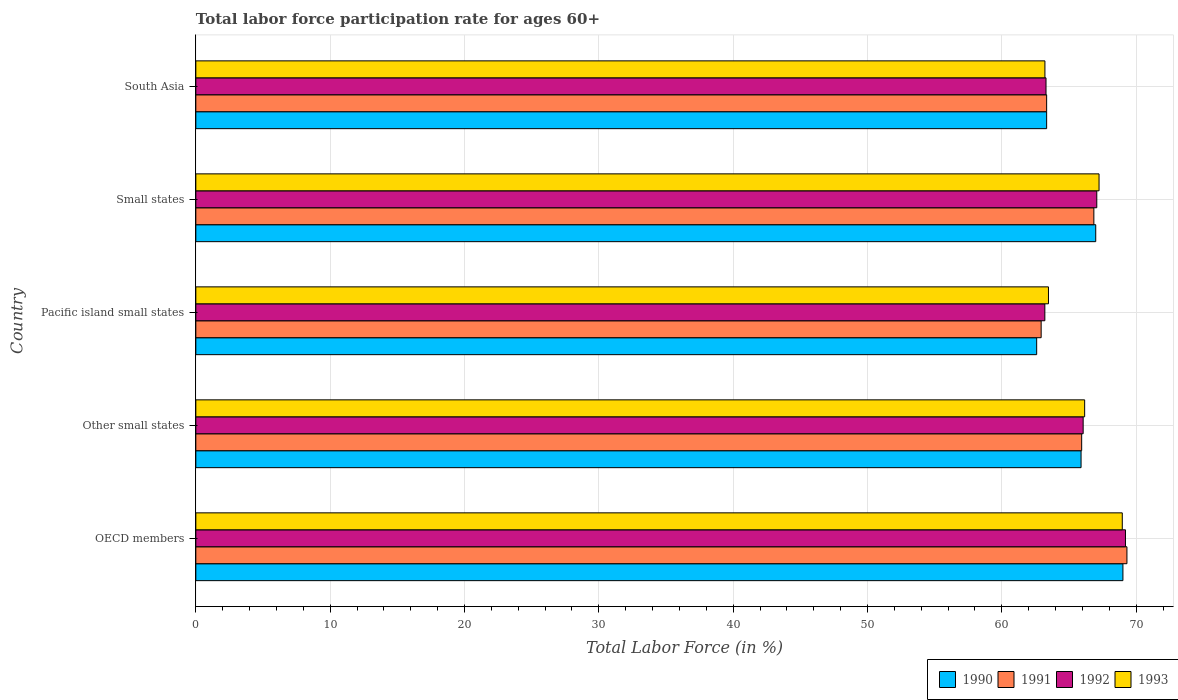How many different coloured bars are there?
Provide a short and direct response. 4. How many groups of bars are there?
Make the answer very short. 5. Are the number of bars on each tick of the Y-axis equal?
Offer a very short reply. Yes. How many bars are there on the 5th tick from the top?
Your response must be concise. 4. What is the label of the 2nd group of bars from the top?
Your answer should be compact. Small states. What is the labor force participation rate in 1991 in Small states?
Offer a terse response. 66.85. Across all countries, what is the maximum labor force participation rate in 1990?
Your answer should be compact. 69.01. Across all countries, what is the minimum labor force participation rate in 1992?
Keep it short and to the point. 63.2. In which country was the labor force participation rate in 1991 minimum?
Offer a terse response. Pacific island small states. What is the total labor force participation rate in 1992 in the graph?
Make the answer very short. 328.81. What is the difference between the labor force participation rate in 1992 in Other small states and that in Pacific island small states?
Offer a terse response. 2.85. What is the difference between the labor force participation rate in 1993 in Other small states and the labor force participation rate in 1990 in Small states?
Keep it short and to the point. -0.82. What is the average labor force participation rate in 1990 per country?
Make the answer very short. 65.57. What is the difference between the labor force participation rate in 1990 and labor force participation rate in 1991 in South Asia?
Your answer should be very brief. 1.5278917210537202e-5. In how many countries, is the labor force participation rate in 1992 greater than 18 %?
Your answer should be compact. 5. What is the ratio of the labor force participation rate in 1993 in Pacific island small states to that in South Asia?
Offer a very short reply. 1. What is the difference between the highest and the second highest labor force participation rate in 1993?
Make the answer very short. 1.73. What is the difference between the highest and the lowest labor force participation rate in 1991?
Provide a short and direct response. 6.39. What does the 2nd bar from the bottom in South Asia represents?
Ensure brevity in your answer.  1991. How many bars are there?
Make the answer very short. 20. How many countries are there in the graph?
Provide a succinct answer. 5. Are the values on the major ticks of X-axis written in scientific E-notation?
Make the answer very short. No. Does the graph contain any zero values?
Your answer should be compact. No. Does the graph contain grids?
Your answer should be very brief. Yes. Where does the legend appear in the graph?
Keep it short and to the point. Bottom right. How many legend labels are there?
Give a very brief answer. 4. What is the title of the graph?
Offer a very short reply. Total labor force participation rate for ages 60+. What is the label or title of the X-axis?
Offer a terse response. Total Labor Force (in %). What is the Total Labor Force (in %) in 1990 in OECD members?
Make the answer very short. 69.01. What is the Total Labor Force (in %) of 1991 in OECD members?
Keep it short and to the point. 69.31. What is the Total Labor Force (in %) of 1992 in OECD members?
Offer a terse response. 69.2. What is the Total Labor Force (in %) of 1993 in OECD members?
Keep it short and to the point. 68.97. What is the Total Labor Force (in %) in 1990 in Other small states?
Give a very brief answer. 65.9. What is the Total Labor Force (in %) of 1991 in Other small states?
Provide a short and direct response. 65.94. What is the Total Labor Force (in %) of 1992 in Other small states?
Ensure brevity in your answer.  66.05. What is the Total Labor Force (in %) of 1993 in Other small states?
Keep it short and to the point. 66.16. What is the Total Labor Force (in %) of 1990 in Pacific island small states?
Your response must be concise. 62.59. What is the Total Labor Force (in %) of 1991 in Pacific island small states?
Your answer should be very brief. 62.93. What is the Total Labor Force (in %) of 1992 in Pacific island small states?
Give a very brief answer. 63.2. What is the Total Labor Force (in %) in 1993 in Pacific island small states?
Your answer should be compact. 63.47. What is the Total Labor Force (in %) of 1990 in Small states?
Offer a terse response. 66.99. What is the Total Labor Force (in %) of 1991 in Small states?
Provide a succinct answer. 66.85. What is the Total Labor Force (in %) in 1992 in Small states?
Make the answer very short. 67.07. What is the Total Labor Force (in %) in 1993 in Small states?
Offer a terse response. 67.24. What is the Total Labor Force (in %) of 1990 in South Asia?
Offer a terse response. 63.33. What is the Total Labor Force (in %) of 1991 in South Asia?
Provide a short and direct response. 63.33. What is the Total Labor Force (in %) of 1992 in South Asia?
Make the answer very short. 63.29. What is the Total Labor Force (in %) of 1993 in South Asia?
Provide a succinct answer. 63.21. Across all countries, what is the maximum Total Labor Force (in %) in 1990?
Your answer should be very brief. 69.01. Across all countries, what is the maximum Total Labor Force (in %) in 1991?
Give a very brief answer. 69.31. Across all countries, what is the maximum Total Labor Force (in %) in 1992?
Ensure brevity in your answer.  69.2. Across all countries, what is the maximum Total Labor Force (in %) of 1993?
Ensure brevity in your answer.  68.97. Across all countries, what is the minimum Total Labor Force (in %) of 1990?
Your answer should be very brief. 62.59. Across all countries, what is the minimum Total Labor Force (in %) of 1991?
Offer a very short reply. 62.93. Across all countries, what is the minimum Total Labor Force (in %) in 1992?
Offer a terse response. 63.2. Across all countries, what is the minimum Total Labor Force (in %) of 1993?
Your answer should be compact. 63.21. What is the total Total Labor Force (in %) of 1990 in the graph?
Keep it short and to the point. 327.83. What is the total Total Labor Force (in %) in 1991 in the graph?
Ensure brevity in your answer.  328.36. What is the total Total Labor Force (in %) of 1992 in the graph?
Give a very brief answer. 328.81. What is the total Total Labor Force (in %) in 1993 in the graph?
Provide a succinct answer. 329.04. What is the difference between the Total Labor Force (in %) in 1990 in OECD members and that in Other small states?
Offer a terse response. 3.12. What is the difference between the Total Labor Force (in %) in 1991 in OECD members and that in Other small states?
Make the answer very short. 3.37. What is the difference between the Total Labor Force (in %) of 1992 in OECD members and that in Other small states?
Offer a very short reply. 3.15. What is the difference between the Total Labor Force (in %) of 1993 in OECD members and that in Other small states?
Give a very brief answer. 2.8. What is the difference between the Total Labor Force (in %) of 1990 in OECD members and that in Pacific island small states?
Provide a short and direct response. 6.42. What is the difference between the Total Labor Force (in %) of 1991 in OECD members and that in Pacific island small states?
Offer a very short reply. 6.39. What is the difference between the Total Labor Force (in %) of 1992 in OECD members and that in Pacific island small states?
Your response must be concise. 6. What is the difference between the Total Labor Force (in %) of 1993 in OECD members and that in Pacific island small states?
Offer a very short reply. 5.49. What is the difference between the Total Labor Force (in %) of 1990 in OECD members and that in Small states?
Offer a terse response. 2.02. What is the difference between the Total Labor Force (in %) in 1991 in OECD members and that in Small states?
Ensure brevity in your answer.  2.46. What is the difference between the Total Labor Force (in %) in 1992 in OECD members and that in Small states?
Offer a very short reply. 2.14. What is the difference between the Total Labor Force (in %) of 1993 in OECD members and that in Small states?
Your response must be concise. 1.73. What is the difference between the Total Labor Force (in %) of 1990 in OECD members and that in South Asia?
Ensure brevity in your answer.  5.68. What is the difference between the Total Labor Force (in %) of 1991 in OECD members and that in South Asia?
Provide a succinct answer. 5.98. What is the difference between the Total Labor Force (in %) of 1992 in OECD members and that in South Asia?
Ensure brevity in your answer.  5.92. What is the difference between the Total Labor Force (in %) in 1993 in OECD members and that in South Asia?
Your answer should be very brief. 5.76. What is the difference between the Total Labor Force (in %) of 1990 in Other small states and that in Pacific island small states?
Give a very brief answer. 3.3. What is the difference between the Total Labor Force (in %) in 1991 in Other small states and that in Pacific island small states?
Your answer should be compact. 3.02. What is the difference between the Total Labor Force (in %) of 1992 in Other small states and that in Pacific island small states?
Provide a succinct answer. 2.85. What is the difference between the Total Labor Force (in %) in 1993 in Other small states and that in Pacific island small states?
Provide a succinct answer. 2.69. What is the difference between the Total Labor Force (in %) in 1990 in Other small states and that in Small states?
Make the answer very short. -1.09. What is the difference between the Total Labor Force (in %) of 1991 in Other small states and that in Small states?
Keep it short and to the point. -0.91. What is the difference between the Total Labor Force (in %) of 1992 in Other small states and that in Small states?
Provide a succinct answer. -1.01. What is the difference between the Total Labor Force (in %) of 1993 in Other small states and that in Small states?
Keep it short and to the point. -1.07. What is the difference between the Total Labor Force (in %) in 1990 in Other small states and that in South Asia?
Your answer should be very brief. 2.56. What is the difference between the Total Labor Force (in %) of 1991 in Other small states and that in South Asia?
Offer a terse response. 2.61. What is the difference between the Total Labor Force (in %) of 1992 in Other small states and that in South Asia?
Your answer should be compact. 2.77. What is the difference between the Total Labor Force (in %) of 1993 in Other small states and that in South Asia?
Your answer should be very brief. 2.96. What is the difference between the Total Labor Force (in %) in 1990 in Pacific island small states and that in Small states?
Give a very brief answer. -4.4. What is the difference between the Total Labor Force (in %) in 1991 in Pacific island small states and that in Small states?
Give a very brief answer. -3.92. What is the difference between the Total Labor Force (in %) of 1992 in Pacific island small states and that in Small states?
Make the answer very short. -3.87. What is the difference between the Total Labor Force (in %) of 1993 in Pacific island small states and that in Small states?
Ensure brevity in your answer.  -3.77. What is the difference between the Total Labor Force (in %) of 1990 in Pacific island small states and that in South Asia?
Your response must be concise. -0.74. What is the difference between the Total Labor Force (in %) of 1991 in Pacific island small states and that in South Asia?
Offer a very short reply. -0.41. What is the difference between the Total Labor Force (in %) in 1992 in Pacific island small states and that in South Asia?
Offer a very short reply. -0.09. What is the difference between the Total Labor Force (in %) in 1993 in Pacific island small states and that in South Asia?
Your answer should be compact. 0.26. What is the difference between the Total Labor Force (in %) of 1990 in Small states and that in South Asia?
Give a very brief answer. 3.66. What is the difference between the Total Labor Force (in %) in 1991 in Small states and that in South Asia?
Give a very brief answer. 3.51. What is the difference between the Total Labor Force (in %) of 1992 in Small states and that in South Asia?
Your answer should be compact. 3.78. What is the difference between the Total Labor Force (in %) in 1993 in Small states and that in South Asia?
Your answer should be very brief. 4.03. What is the difference between the Total Labor Force (in %) of 1990 in OECD members and the Total Labor Force (in %) of 1991 in Other small states?
Keep it short and to the point. 3.07. What is the difference between the Total Labor Force (in %) in 1990 in OECD members and the Total Labor Force (in %) in 1992 in Other small states?
Your answer should be very brief. 2.96. What is the difference between the Total Labor Force (in %) in 1990 in OECD members and the Total Labor Force (in %) in 1993 in Other small states?
Offer a very short reply. 2.85. What is the difference between the Total Labor Force (in %) in 1991 in OECD members and the Total Labor Force (in %) in 1992 in Other small states?
Your answer should be compact. 3.26. What is the difference between the Total Labor Force (in %) of 1991 in OECD members and the Total Labor Force (in %) of 1993 in Other small states?
Your response must be concise. 3.15. What is the difference between the Total Labor Force (in %) in 1992 in OECD members and the Total Labor Force (in %) in 1993 in Other small states?
Offer a very short reply. 3.04. What is the difference between the Total Labor Force (in %) in 1990 in OECD members and the Total Labor Force (in %) in 1991 in Pacific island small states?
Provide a short and direct response. 6.09. What is the difference between the Total Labor Force (in %) in 1990 in OECD members and the Total Labor Force (in %) in 1992 in Pacific island small states?
Provide a succinct answer. 5.81. What is the difference between the Total Labor Force (in %) in 1990 in OECD members and the Total Labor Force (in %) in 1993 in Pacific island small states?
Your response must be concise. 5.54. What is the difference between the Total Labor Force (in %) of 1991 in OECD members and the Total Labor Force (in %) of 1992 in Pacific island small states?
Keep it short and to the point. 6.11. What is the difference between the Total Labor Force (in %) in 1991 in OECD members and the Total Labor Force (in %) in 1993 in Pacific island small states?
Your response must be concise. 5.84. What is the difference between the Total Labor Force (in %) of 1992 in OECD members and the Total Labor Force (in %) of 1993 in Pacific island small states?
Your answer should be very brief. 5.73. What is the difference between the Total Labor Force (in %) of 1990 in OECD members and the Total Labor Force (in %) of 1991 in Small states?
Your response must be concise. 2.16. What is the difference between the Total Labor Force (in %) of 1990 in OECD members and the Total Labor Force (in %) of 1992 in Small states?
Make the answer very short. 1.95. What is the difference between the Total Labor Force (in %) in 1990 in OECD members and the Total Labor Force (in %) in 1993 in Small states?
Your answer should be very brief. 1.78. What is the difference between the Total Labor Force (in %) of 1991 in OECD members and the Total Labor Force (in %) of 1992 in Small states?
Provide a short and direct response. 2.25. What is the difference between the Total Labor Force (in %) in 1991 in OECD members and the Total Labor Force (in %) in 1993 in Small states?
Your answer should be very brief. 2.08. What is the difference between the Total Labor Force (in %) of 1992 in OECD members and the Total Labor Force (in %) of 1993 in Small states?
Provide a short and direct response. 1.97. What is the difference between the Total Labor Force (in %) of 1990 in OECD members and the Total Labor Force (in %) of 1991 in South Asia?
Provide a short and direct response. 5.68. What is the difference between the Total Labor Force (in %) of 1990 in OECD members and the Total Labor Force (in %) of 1992 in South Asia?
Your answer should be very brief. 5.72. What is the difference between the Total Labor Force (in %) of 1990 in OECD members and the Total Labor Force (in %) of 1993 in South Asia?
Offer a very short reply. 5.81. What is the difference between the Total Labor Force (in %) of 1991 in OECD members and the Total Labor Force (in %) of 1992 in South Asia?
Give a very brief answer. 6.02. What is the difference between the Total Labor Force (in %) in 1991 in OECD members and the Total Labor Force (in %) in 1993 in South Asia?
Provide a short and direct response. 6.11. What is the difference between the Total Labor Force (in %) in 1992 in OECD members and the Total Labor Force (in %) in 1993 in South Asia?
Your answer should be very brief. 6. What is the difference between the Total Labor Force (in %) of 1990 in Other small states and the Total Labor Force (in %) of 1991 in Pacific island small states?
Your answer should be compact. 2.97. What is the difference between the Total Labor Force (in %) in 1990 in Other small states and the Total Labor Force (in %) in 1992 in Pacific island small states?
Make the answer very short. 2.7. What is the difference between the Total Labor Force (in %) of 1990 in Other small states and the Total Labor Force (in %) of 1993 in Pacific island small states?
Your answer should be compact. 2.43. What is the difference between the Total Labor Force (in %) of 1991 in Other small states and the Total Labor Force (in %) of 1992 in Pacific island small states?
Give a very brief answer. 2.74. What is the difference between the Total Labor Force (in %) in 1991 in Other small states and the Total Labor Force (in %) in 1993 in Pacific island small states?
Offer a terse response. 2.47. What is the difference between the Total Labor Force (in %) in 1992 in Other small states and the Total Labor Force (in %) in 1993 in Pacific island small states?
Provide a succinct answer. 2.58. What is the difference between the Total Labor Force (in %) of 1990 in Other small states and the Total Labor Force (in %) of 1991 in Small states?
Offer a very short reply. -0.95. What is the difference between the Total Labor Force (in %) in 1990 in Other small states and the Total Labor Force (in %) in 1992 in Small states?
Provide a short and direct response. -1.17. What is the difference between the Total Labor Force (in %) of 1990 in Other small states and the Total Labor Force (in %) of 1993 in Small states?
Your answer should be very brief. -1.34. What is the difference between the Total Labor Force (in %) of 1991 in Other small states and the Total Labor Force (in %) of 1992 in Small states?
Your answer should be compact. -1.12. What is the difference between the Total Labor Force (in %) of 1991 in Other small states and the Total Labor Force (in %) of 1993 in Small states?
Your answer should be very brief. -1.29. What is the difference between the Total Labor Force (in %) of 1992 in Other small states and the Total Labor Force (in %) of 1993 in Small states?
Your response must be concise. -1.18. What is the difference between the Total Labor Force (in %) in 1990 in Other small states and the Total Labor Force (in %) in 1991 in South Asia?
Give a very brief answer. 2.56. What is the difference between the Total Labor Force (in %) of 1990 in Other small states and the Total Labor Force (in %) of 1992 in South Asia?
Provide a succinct answer. 2.61. What is the difference between the Total Labor Force (in %) in 1990 in Other small states and the Total Labor Force (in %) in 1993 in South Asia?
Ensure brevity in your answer.  2.69. What is the difference between the Total Labor Force (in %) in 1991 in Other small states and the Total Labor Force (in %) in 1992 in South Asia?
Give a very brief answer. 2.65. What is the difference between the Total Labor Force (in %) in 1991 in Other small states and the Total Labor Force (in %) in 1993 in South Asia?
Ensure brevity in your answer.  2.74. What is the difference between the Total Labor Force (in %) of 1992 in Other small states and the Total Labor Force (in %) of 1993 in South Asia?
Offer a very short reply. 2.85. What is the difference between the Total Labor Force (in %) in 1990 in Pacific island small states and the Total Labor Force (in %) in 1991 in Small states?
Keep it short and to the point. -4.26. What is the difference between the Total Labor Force (in %) in 1990 in Pacific island small states and the Total Labor Force (in %) in 1992 in Small states?
Give a very brief answer. -4.47. What is the difference between the Total Labor Force (in %) in 1990 in Pacific island small states and the Total Labor Force (in %) in 1993 in Small states?
Your response must be concise. -4.64. What is the difference between the Total Labor Force (in %) of 1991 in Pacific island small states and the Total Labor Force (in %) of 1992 in Small states?
Make the answer very short. -4.14. What is the difference between the Total Labor Force (in %) of 1991 in Pacific island small states and the Total Labor Force (in %) of 1993 in Small states?
Your response must be concise. -4.31. What is the difference between the Total Labor Force (in %) in 1992 in Pacific island small states and the Total Labor Force (in %) in 1993 in Small states?
Provide a short and direct response. -4.03. What is the difference between the Total Labor Force (in %) in 1990 in Pacific island small states and the Total Labor Force (in %) in 1991 in South Asia?
Make the answer very short. -0.74. What is the difference between the Total Labor Force (in %) of 1990 in Pacific island small states and the Total Labor Force (in %) of 1992 in South Asia?
Your answer should be very brief. -0.7. What is the difference between the Total Labor Force (in %) of 1990 in Pacific island small states and the Total Labor Force (in %) of 1993 in South Asia?
Keep it short and to the point. -0.61. What is the difference between the Total Labor Force (in %) of 1991 in Pacific island small states and the Total Labor Force (in %) of 1992 in South Asia?
Your answer should be compact. -0.36. What is the difference between the Total Labor Force (in %) of 1991 in Pacific island small states and the Total Labor Force (in %) of 1993 in South Asia?
Provide a succinct answer. -0.28. What is the difference between the Total Labor Force (in %) of 1992 in Pacific island small states and the Total Labor Force (in %) of 1993 in South Asia?
Keep it short and to the point. -0.01. What is the difference between the Total Labor Force (in %) of 1990 in Small states and the Total Labor Force (in %) of 1991 in South Asia?
Your response must be concise. 3.66. What is the difference between the Total Labor Force (in %) in 1990 in Small states and the Total Labor Force (in %) in 1992 in South Asia?
Provide a short and direct response. 3.7. What is the difference between the Total Labor Force (in %) in 1990 in Small states and the Total Labor Force (in %) in 1993 in South Asia?
Provide a short and direct response. 3.78. What is the difference between the Total Labor Force (in %) in 1991 in Small states and the Total Labor Force (in %) in 1992 in South Asia?
Your answer should be compact. 3.56. What is the difference between the Total Labor Force (in %) in 1991 in Small states and the Total Labor Force (in %) in 1993 in South Asia?
Offer a terse response. 3.64. What is the difference between the Total Labor Force (in %) in 1992 in Small states and the Total Labor Force (in %) in 1993 in South Asia?
Offer a very short reply. 3.86. What is the average Total Labor Force (in %) in 1990 per country?
Your answer should be very brief. 65.56. What is the average Total Labor Force (in %) in 1991 per country?
Provide a succinct answer. 65.67. What is the average Total Labor Force (in %) in 1992 per country?
Offer a very short reply. 65.76. What is the average Total Labor Force (in %) of 1993 per country?
Keep it short and to the point. 65.81. What is the difference between the Total Labor Force (in %) in 1990 and Total Labor Force (in %) in 1991 in OECD members?
Make the answer very short. -0.3. What is the difference between the Total Labor Force (in %) in 1990 and Total Labor Force (in %) in 1992 in OECD members?
Your response must be concise. -0.19. What is the difference between the Total Labor Force (in %) in 1990 and Total Labor Force (in %) in 1993 in OECD members?
Offer a very short reply. 0.05. What is the difference between the Total Labor Force (in %) of 1991 and Total Labor Force (in %) of 1992 in OECD members?
Provide a succinct answer. 0.11. What is the difference between the Total Labor Force (in %) in 1991 and Total Labor Force (in %) in 1993 in OECD members?
Give a very brief answer. 0.35. What is the difference between the Total Labor Force (in %) in 1992 and Total Labor Force (in %) in 1993 in OECD members?
Ensure brevity in your answer.  0.24. What is the difference between the Total Labor Force (in %) in 1990 and Total Labor Force (in %) in 1991 in Other small states?
Your answer should be very brief. -0.05. What is the difference between the Total Labor Force (in %) of 1990 and Total Labor Force (in %) of 1992 in Other small states?
Your answer should be compact. -0.16. What is the difference between the Total Labor Force (in %) in 1990 and Total Labor Force (in %) in 1993 in Other small states?
Your answer should be compact. -0.27. What is the difference between the Total Labor Force (in %) in 1991 and Total Labor Force (in %) in 1992 in Other small states?
Give a very brief answer. -0.11. What is the difference between the Total Labor Force (in %) of 1991 and Total Labor Force (in %) of 1993 in Other small states?
Provide a short and direct response. -0.22. What is the difference between the Total Labor Force (in %) in 1992 and Total Labor Force (in %) in 1993 in Other small states?
Provide a short and direct response. -0.11. What is the difference between the Total Labor Force (in %) of 1990 and Total Labor Force (in %) of 1991 in Pacific island small states?
Ensure brevity in your answer.  -0.33. What is the difference between the Total Labor Force (in %) in 1990 and Total Labor Force (in %) in 1992 in Pacific island small states?
Your response must be concise. -0.61. What is the difference between the Total Labor Force (in %) in 1990 and Total Labor Force (in %) in 1993 in Pacific island small states?
Ensure brevity in your answer.  -0.88. What is the difference between the Total Labor Force (in %) in 1991 and Total Labor Force (in %) in 1992 in Pacific island small states?
Provide a succinct answer. -0.27. What is the difference between the Total Labor Force (in %) in 1991 and Total Labor Force (in %) in 1993 in Pacific island small states?
Provide a succinct answer. -0.54. What is the difference between the Total Labor Force (in %) in 1992 and Total Labor Force (in %) in 1993 in Pacific island small states?
Give a very brief answer. -0.27. What is the difference between the Total Labor Force (in %) of 1990 and Total Labor Force (in %) of 1991 in Small states?
Offer a terse response. 0.14. What is the difference between the Total Labor Force (in %) of 1990 and Total Labor Force (in %) of 1992 in Small states?
Provide a short and direct response. -0.08. What is the difference between the Total Labor Force (in %) of 1990 and Total Labor Force (in %) of 1993 in Small states?
Offer a terse response. -0.25. What is the difference between the Total Labor Force (in %) of 1991 and Total Labor Force (in %) of 1992 in Small states?
Offer a very short reply. -0.22. What is the difference between the Total Labor Force (in %) of 1991 and Total Labor Force (in %) of 1993 in Small states?
Ensure brevity in your answer.  -0.39. What is the difference between the Total Labor Force (in %) of 1992 and Total Labor Force (in %) of 1993 in Small states?
Give a very brief answer. -0.17. What is the difference between the Total Labor Force (in %) of 1990 and Total Labor Force (in %) of 1992 in South Asia?
Give a very brief answer. 0.05. What is the difference between the Total Labor Force (in %) in 1990 and Total Labor Force (in %) in 1993 in South Asia?
Offer a terse response. 0.13. What is the difference between the Total Labor Force (in %) of 1991 and Total Labor Force (in %) of 1992 in South Asia?
Your answer should be compact. 0.05. What is the difference between the Total Labor Force (in %) of 1991 and Total Labor Force (in %) of 1993 in South Asia?
Make the answer very short. 0.13. What is the difference between the Total Labor Force (in %) in 1992 and Total Labor Force (in %) in 1993 in South Asia?
Provide a succinct answer. 0.08. What is the ratio of the Total Labor Force (in %) of 1990 in OECD members to that in Other small states?
Provide a short and direct response. 1.05. What is the ratio of the Total Labor Force (in %) of 1991 in OECD members to that in Other small states?
Your response must be concise. 1.05. What is the ratio of the Total Labor Force (in %) in 1992 in OECD members to that in Other small states?
Ensure brevity in your answer.  1.05. What is the ratio of the Total Labor Force (in %) in 1993 in OECD members to that in Other small states?
Your response must be concise. 1.04. What is the ratio of the Total Labor Force (in %) of 1990 in OECD members to that in Pacific island small states?
Your answer should be very brief. 1.1. What is the ratio of the Total Labor Force (in %) in 1991 in OECD members to that in Pacific island small states?
Offer a very short reply. 1.1. What is the ratio of the Total Labor Force (in %) of 1992 in OECD members to that in Pacific island small states?
Give a very brief answer. 1.09. What is the ratio of the Total Labor Force (in %) of 1993 in OECD members to that in Pacific island small states?
Make the answer very short. 1.09. What is the ratio of the Total Labor Force (in %) of 1990 in OECD members to that in Small states?
Provide a succinct answer. 1.03. What is the ratio of the Total Labor Force (in %) in 1991 in OECD members to that in Small states?
Offer a very short reply. 1.04. What is the ratio of the Total Labor Force (in %) of 1992 in OECD members to that in Small states?
Provide a succinct answer. 1.03. What is the ratio of the Total Labor Force (in %) in 1993 in OECD members to that in Small states?
Your response must be concise. 1.03. What is the ratio of the Total Labor Force (in %) in 1990 in OECD members to that in South Asia?
Offer a terse response. 1.09. What is the ratio of the Total Labor Force (in %) of 1991 in OECD members to that in South Asia?
Give a very brief answer. 1.09. What is the ratio of the Total Labor Force (in %) in 1992 in OECD members to that in South Asia?
Keep it short and to the point. 1.09. What is the ratio of the Total Labor Force (in %) in 1993 in OECD members to that in South Asia?
Your answer should be very brief. 1.09. What is the ratio of the Total Labor Force (in %) in 1990 in Other small states to that in Pacific island small states?
Provide a short and direct response. 1.05. What is the ratio of the Total Labor Force (in %) in 1991 in Other small states to that in Pacific island small states?
Offer a very short reply. 1.05. What is the ratio of the Total Labor Force (in %) of 1992 in Other small states to that in Pacific island small states?
Make the answer very short. 1.05. What is the ratio of the Total Labor Force (in %) in 1993 in Other small states to that in Pacific island small states?
Give a very brief answer. 1.04. What is the ratio of the Total Labor Force (in %) of 1990 in Other small states to that in Small states?
Offer a very short reply. 0.98. What is the ratio of the Total Labor Force (in %) of 1991 in Other small states to that in Small states?
Ensure brevity in your answer.  0.99. What is the ratio of the Total Labor Force (in %) of 1992 in Other small states to that in Small states?
Offer a very short reply. 0.98. What is the ratio of the Total Labor Force (in %) in 1993 in Other small states to that in Small states?
Ensure brevity in your answer.  0.98. What is the ratio of the Total Labor Force (in %) of 1990 in Other small states to that in South Asia?
Offer a very short reply. 1.04. What is the ratio of the Total Labor Force (in %) in 1991 in Other small states to that in South Asia?
Make the answer very short. 1.04. What is the ratio of the Total Labor Force (in %) of 1992 in Other small states to that in South Asia?
Provide a short and direct response. 1.04. What is the ratio of the Total Labor Force (in %) in 1993 in Other small states to that in South Asia?
Your response must be concise. 1.05. What is the ratio of the Total Labor Force (in %) of 1990 in Pacific island small states to that in Small states?
Keep it short and to the point. 0.93. What is the ratio of the Total Labor Force (in %) in 1991 in Pacific island small states to that in Small states?
Your answer should be very brief. 0.94. What is the ratio of the Total Labor Force (in %) of 1992 in Pacific island small states to that in Small states?
Make the answer very short. 0.94. What is the ratio of the Total Labor Force (in %) of 1993 in Pacific island small states to that in Small states?
Give a very brief answer. 0.94. What is the ratio of the Total Labor Force (in %) of 1990 in Pacific island small states to that in South Asia?
Your answer should be compact. 0.99. What is the ratio of the Total Labor Force (in %) in 1991 in Pacific island small states to that in South Asia?
Ensure brevity in your answer.  0.99. What is the ratio of the Total Labor Force (in %) of 1992 in Pacific island small states to that in South Asia?
Keep it short and to the point. 1. What is the ratio of the Total Labor Force (in %) in 1993 in Pacific island small states to that in South Asia?
Offer a terse response. 1. What is the ratio of the Total Labor Force (in %) in 1990 in Small states to that in South Asia?
Make the answer very short. 1.06. What is the ratio of the Total Labor Force (in %) in 1991 in Small states to that in South Asia?
Provide a short and direct response. 1.06. What is the ratio of the Total Labor Force (in %) of 1992 in Small states to that in South Asia?
Offer a very short reply. 1.06. What is the ratio of the Total Labor Force (in %) of 1993 in Small states to that in South Asia?
Provide a succinct answer. 1.06. What is the difference between the highest and the second highest Total Labor Force (in %) of 1990?
Keep it short and to the point. 2.02. What is the difference between the highest and the second highest Total Labor Force (in %) in 1991?
Make the answer very short. 2.46. What is the difference between the highest and the second highest Total Labor Force (in %) in 1992?
Your answer should be compact. 2.14. What is the difference between the highest and the second highest Total Labor Force (in %) of 1993?
Ensure brevity in your answer.  1.73. What is the difference between the highest and the lowest Total Labor Force (in %) of 1990?
Your response must be concise. 6.42. What is the difference between the highest and the lowest Total Labor Force (in %) in 1991?
Make the answer very short. 6.39. What is the difference between the highest and the lowest Total Labor Force (in %) in 1992?
Make the answer very short. 6. What is the difference between the highest and the lowest Total Labor Force (in %) in 1993?
Make the answer very short. 5.76. 